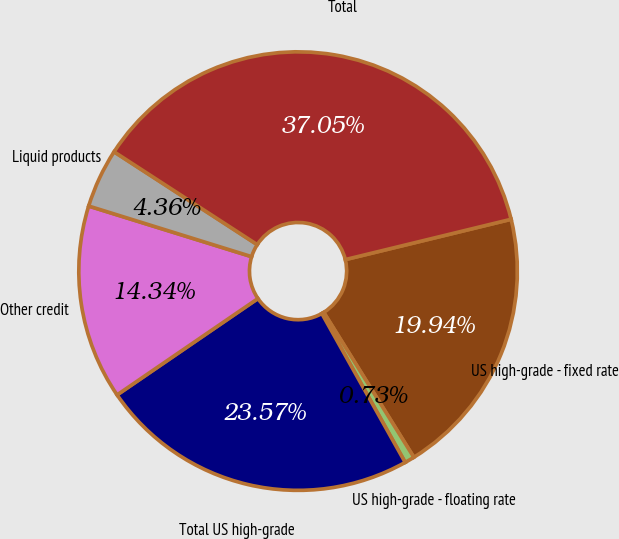Convert chart. <chart><loc_0><loc_0><loc_500><loc_500><pie_chart><fcel>US high-grade - fixed rate<fcel>US high-grade - floating rate<fcel>Total US high-grade<fcel>Other credit<fcel>Liquid products<fcel>Total<nl><fcel>19.94%<fcel>0.73%<fcel>23.57%<fcel>14.34%<fcel>4.36%<fcel>37.04%<nl></chart> 